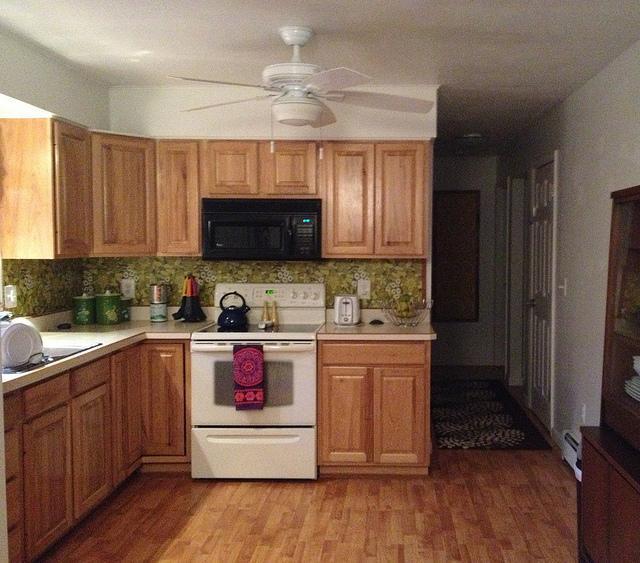How many cabinets are directly above the microwave?
Give a very brief answer. 2. 